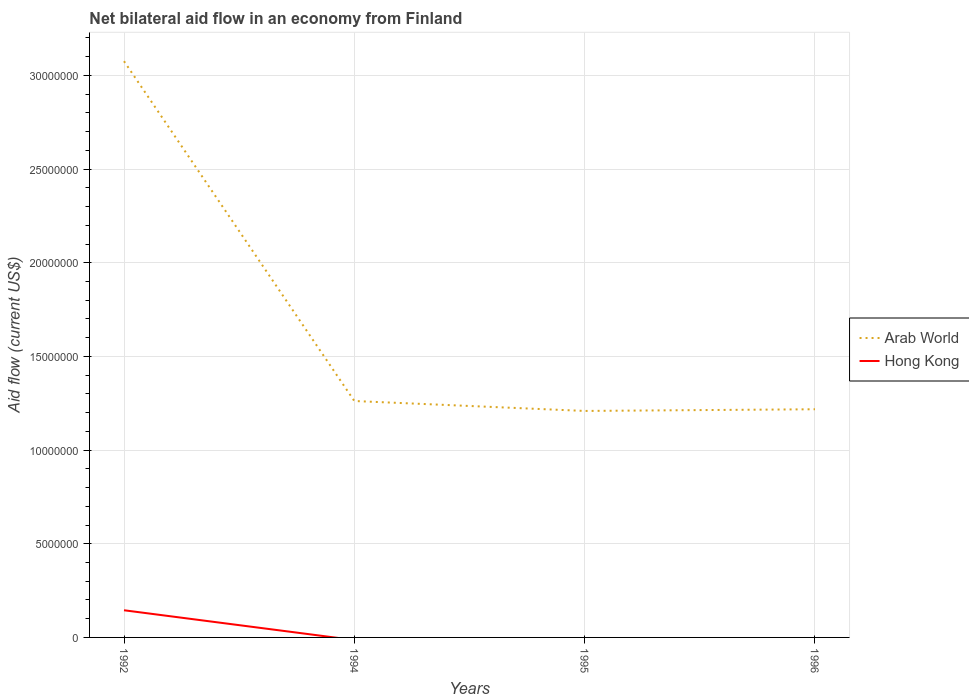How many different coloured lines are there?
Provide a short and direct response. 2. Is the number of lines equal to the number of legend labels?
Your response must be concise. No. Across all years, what is the maximum net bilateral aid flow in Arab World?
Keep it short and to the point. 1.21e+07. What is the total net bilateral aid flow in Arab World in the graph?
Offer a terse response. 1.87e+07. What is the difference between the highest and the second highest net bilateral aid flow in Arab World?
Give a very brief answer. 1.87e+07. Is the net bilateral aid flow in Hong Kong strictly greater than the net bilateral aid flow in Arab World over the years?
Keep it short and to the point. Yes. Does the graph contain any zero values?
Give a very brief answer. Yes. Where does the legend appear in the graph?
Provide a short and direct response. Center right. How are the legend labels stacked?
Keep it short and to the point. Vertical. What is the title of the graph?
Provide a succinct answer. Net bilateral aid flow in an economy from Finland. What is the label or title of the Y-axis?
Make the answer very short. Aid flow (current US$). What is the Aid flow (current US$) in Arab World in 1992?
Your answer should be compact. 3.08e+07. What is the Aid flow (current US$) in Hong Kong in 1992?
Provide a succinct answer. 1.45e+06. What is the Aid flow (current US$) of Arab World in 1994?
Provide a succinct answer. 1.26e+07. What is the Aid flow (current US$) in Arab World in 1995?
Your response must be concise. 1.21e+07. What is the Aid flow (current US$) of Hong Kong in 1995?
Your answer should be compact. 0. What is the Aid flow (current US$) in Arab World in 1996?
Make the answer very short. 1.22e+07. Across all years, what is the maximum Aid flow (current US$) in Arab World?
Make the answer very short. 3.08e+07. Across all years, what is the maximum Aid flow (current US$) of Hong Kong?
Give a very brief answer. 1.45e+06. Across all years, what is the minimum Aid flow (current US$) in Arab World?
Provide a short and direct response. 1.21e+07. What is the total Aid flow (current US$) in Arab World in the graph?
Provide a succinct answer. 6.76e+07. What is the total Aid flow (current US$) of Hong Kong in the graph?
Ensure brevity in your answer.  1.45e+06. What is the difference between the Aid flow (current US$) of Arab World in 1992 and that in 1994?
Your response must be concise. 1.81e+07. What is the difference between the Aid flow (current US$) of Arab World in 1992 and that in 1995?
Provide a succinct answer. 1.87e+07. What is the difference between the Aid flow (current US$) of Arab World in 1992 and that in 1996?
Your answer should be compact. 1.86e+07. What is the difference between the Aid flow (current US$) of Arab World in 1994 and that in 1995?
Your answer should be compact. 5.30e+05. What is the difference between the Aid flow (current US$) of Arab World in 1994 and that in 1996?
Give a very brief answer. 4.40e+05. What is the average Aid flow (current US$) of Arab World per year?
Offer a terse response. 1.69e+07. What is the average Aid flow (current US$) in Hong Kong per year?
Offer a terse response. 3.62e+05. In the year 1992, what is the difference between the Aid flow (current US$) of Arab World and Aid flow (current US$) of Hong Kong?
Give a very brief answer. 2.93e+07. What is the ratio of the Aid flow (current US$) of Arab World in 1992 to that in 1994?
Your response must be concise. 2.44. What is the ratio of the Aid flow (current US$) of Arab World in 1992 to that in 1995?
Offer a terse response. 2.54. What is the ratio of the Aid flow (current US$) in Arab World in 1992 to that in 1996?
Your answer should be compact. 2.53. What is the ratio of the Aid flow (current US$) of Arab World in 1994 to that in 1995?
Keep it short and to the point. 1.04. What is the ratio of the Aid flow (current US$) of Arab World in 1994 to that in 1996?
Make the answer very short. 1.04. What is the difference between the highest and the second highest Aid flow (current US$) of Arab World?
Provide a succinct answer. 1.81e+07. What is the difference between the highest and the lowest Aid flow (current US$) of Arab World?
Keep it short and to the point. 1.87e+07. What is the difference between the highest and the lowest Aid flow (current US$) in Hong Kong?
Your answer should be compact. 1.45e+06. 